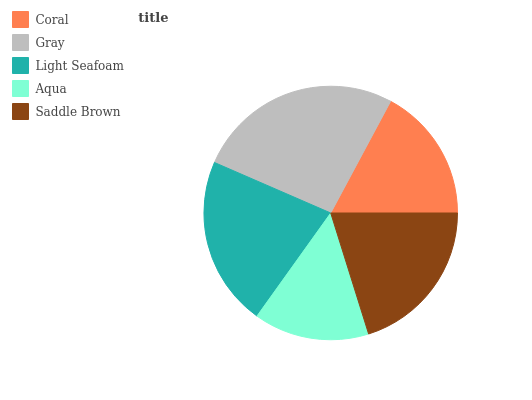Is Aqua the minimum?
Answer yes or no. Yes. Is Gray the maximum?
Answer yes or no. Yes. Is Light Seafoam the minimum?
Answer yes or no. No. Is Light Seafoam the maximum?
Answer yes or no. No. Is Gray greater than Light Seafoam?
Answer yes or no. Yes. Is Light Seafoam less than Gray?
Answer yes or no. Yes. Is Light Seafoam greater than Gray?
Answer yes or no. No. Is Gray less than Light Seafoam?
Answer yes or no. No. Is Saddle Brown the high median?
Answer yes or no. Yes. Is Saddle Brown the low median?
Answer yes or no. Yes. Is Coral the high median?
Answer yes or no. No. Is Light Seafoam the low median?
Answer yes or no. No. 